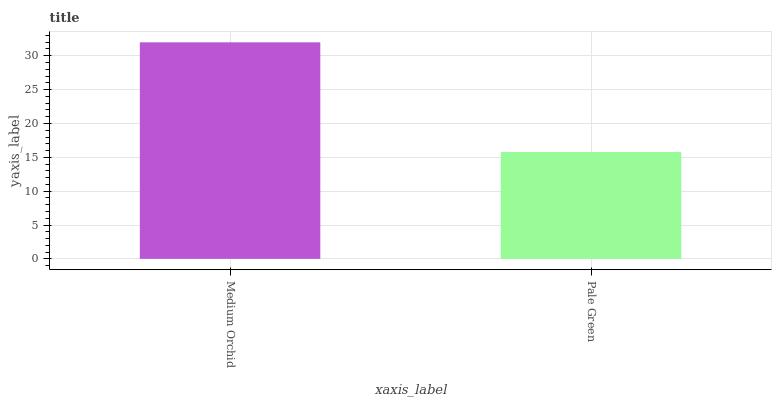Is Pale Green the minimum?
Answer yes or no. Yes. Is Medium Orchid the maximum?
Answer yes or no. Yes. Is Pale Green the maximum?
Answer yes or no. No. Is Medium Orchid greater than Pale Green?
Answer yes or no. Yes. Is Pale Green less than Medium Orchid?
Answer yes or no. Yes. Is Pale Green greater than Medium Orchid?
Answer yes or no. No. Is Medium Orchid less than Pale Green?
Answer yes or no. No. Is Medium Orchid the high median?
Answer yes or no. Yes. Is Pale Green the low median?
Answer yes or no. Yes. Is Pale Green the high median?
Answer yes or no. No. Is Medium Orchid the low median?
Answer yes or no. No. 